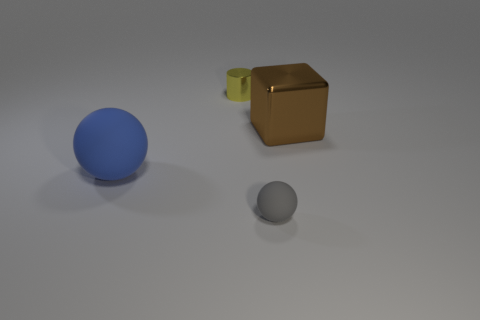Is there any other thing that has the same size as the metal block?
Give a very brief answer. Yes. Is the number of tiny balls on the left side of the small matte sphere less than the number of tiny spheres left of the big rubber ball?
Give a very brief answer. No. Are there any other things that have the same shape as the large blue rubber thing?
Offer a terse response. Yes. How many metal objects are right of the thing behind the large thing behind the blue ball?
Provide a succinct answer. 1. There is a large matte thing; what number of shiny blocks are behind it?
Ensure brevity in your answer.  1. What number of big objects have the same material as the cylinder?
Your answer should be very brief. 1. There is a big thing that is the same material as the small gray sphere; what color is it?
Ensure brevity in your answer.  Blue. What is the big thing on the left side of the thing in front of the large thing that is in front of the large brown block made of?
Ensure brevity in your answer.  Rubber. Do the matte sphere right of the blue sphere and the big brown metal object have the same size?
Provide a short and direct response. No. What number of large things are gray rubber spheres or shiny objects?
Keep it short and to the point. 1. 